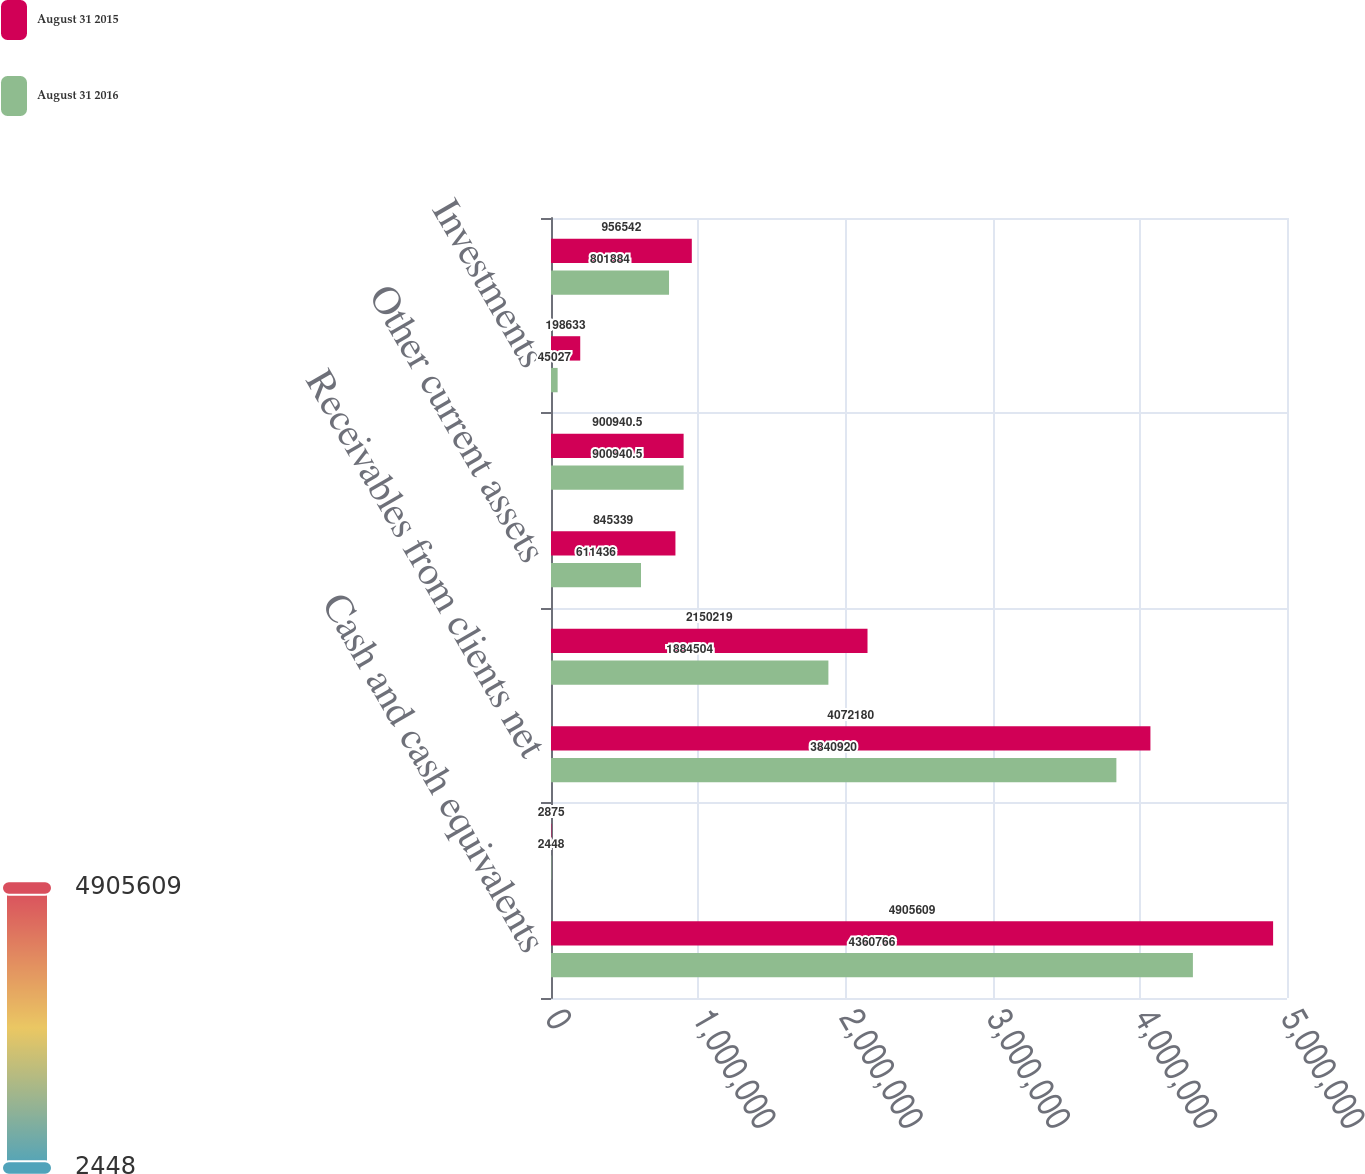<chart> <loc_0><loc_0><loc_500><loc_500><stacked_bar_chart><ecel><fcel>Cash and cash equivalents<fcel>Short-term investments<fcel>Receivables from clients net<fcel>Unbilled services net<fcel>Other current assets<fcel>Total current assets<fcel>Investments<fcel>Property and equipment net<nl><fcel>August 31 2015<fcel>4.90561e+06<fcel>2875<fcel>4.07218e+06<fcel>2.15022e+06<fcel>845339<fcel>900940<fcel>198633<fcel>956542<nl><fcel>August 31 2016<fcel>4.36077e+06<fcel>2448<fcel>3.84092e+06<fcel>1.8845e+06<fcel>611436<fcel>900940<fcel>45027<fcel>801884<nl></chart> 